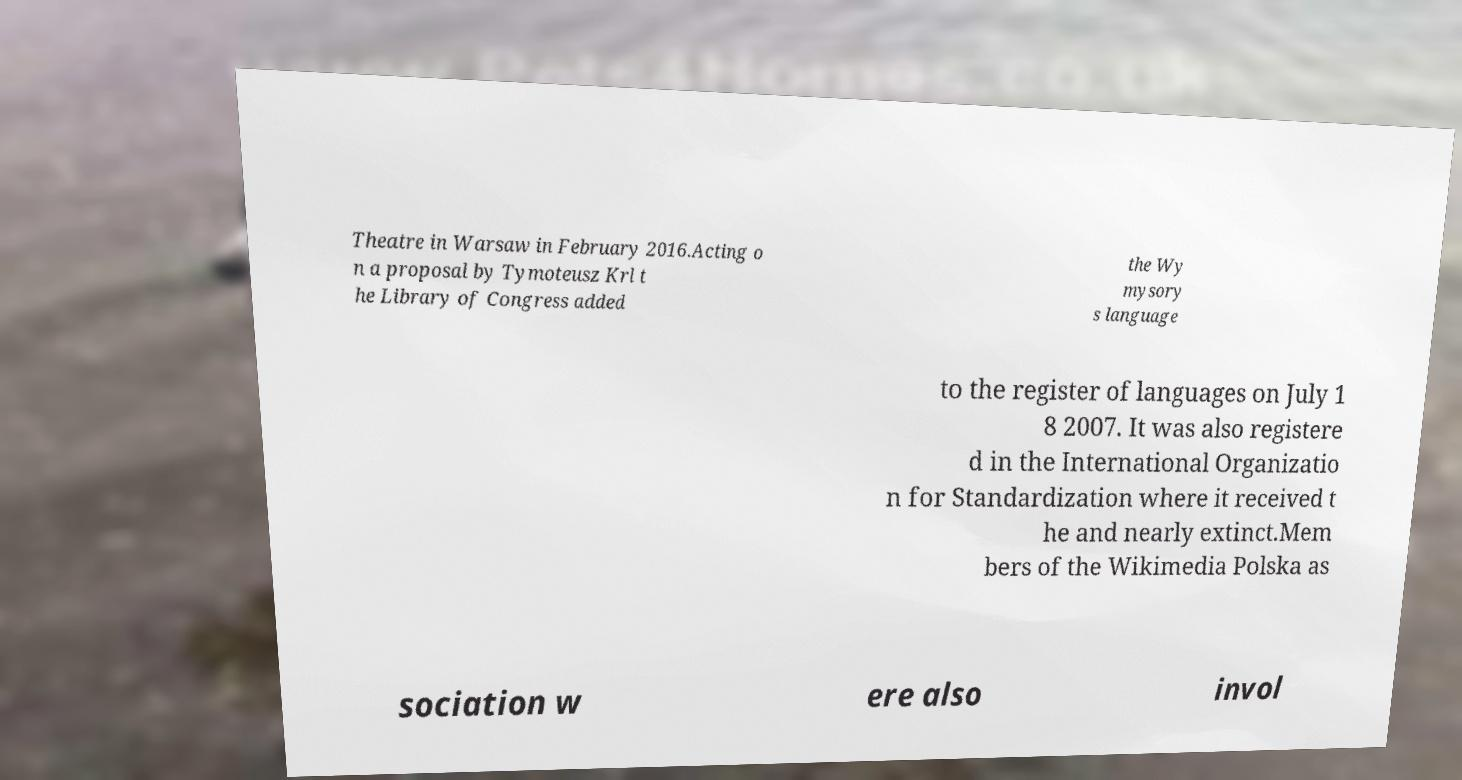What messages or text are displayed in this image? I need them in a readable, typed format. Theatre in Warsaw in February 2016.Acting o n a proposal by Tymoteusz Krl t he Library of Congress added the Wy mysory s language to the register of languages on July 1 8 2007. It was also registere d in the International Organizatio n for Standardization where it received t he and nearly extinct.Mem bers of the Wikimedia Polska as sociation w ere also invol 